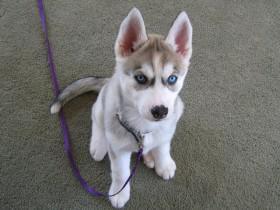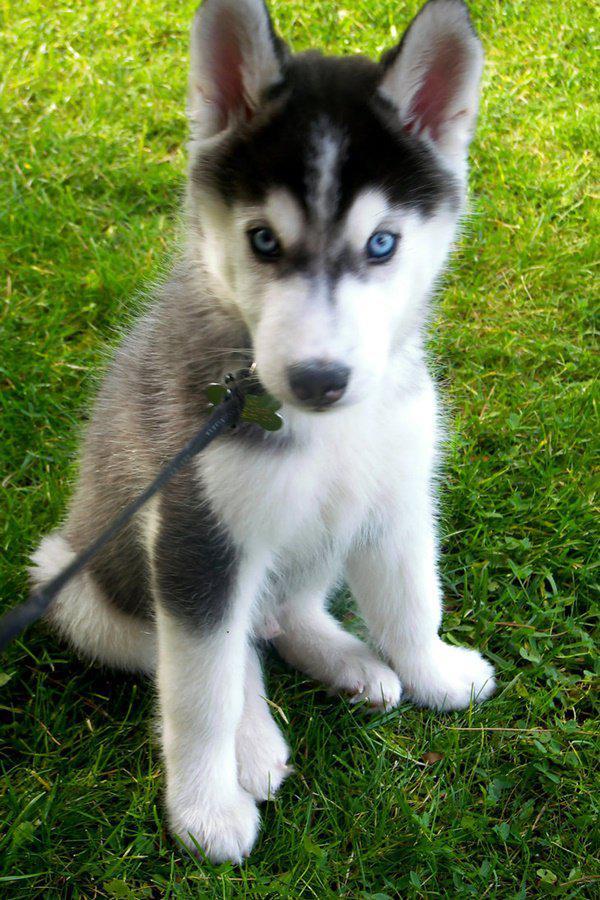The first image is the image on the left, the second image is the image on the right. Considering the images on both sides, is "A dog is sitting in the grass in the image on the left." valid? Answer yes or no. No. The first image is the image on the left, the second image is the image on the right. Assess this claim about the two images: "Each image contains one forward-facing husky in the foreground, at least one dog has blue eyes, and one dog sits upright on green grass.". Correct or not? Answer yes or no. Yes. 